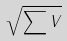<formula> <loc_0><loc_0><loc_500><loc_500>\sqrt { \sum { V } }</formula> 